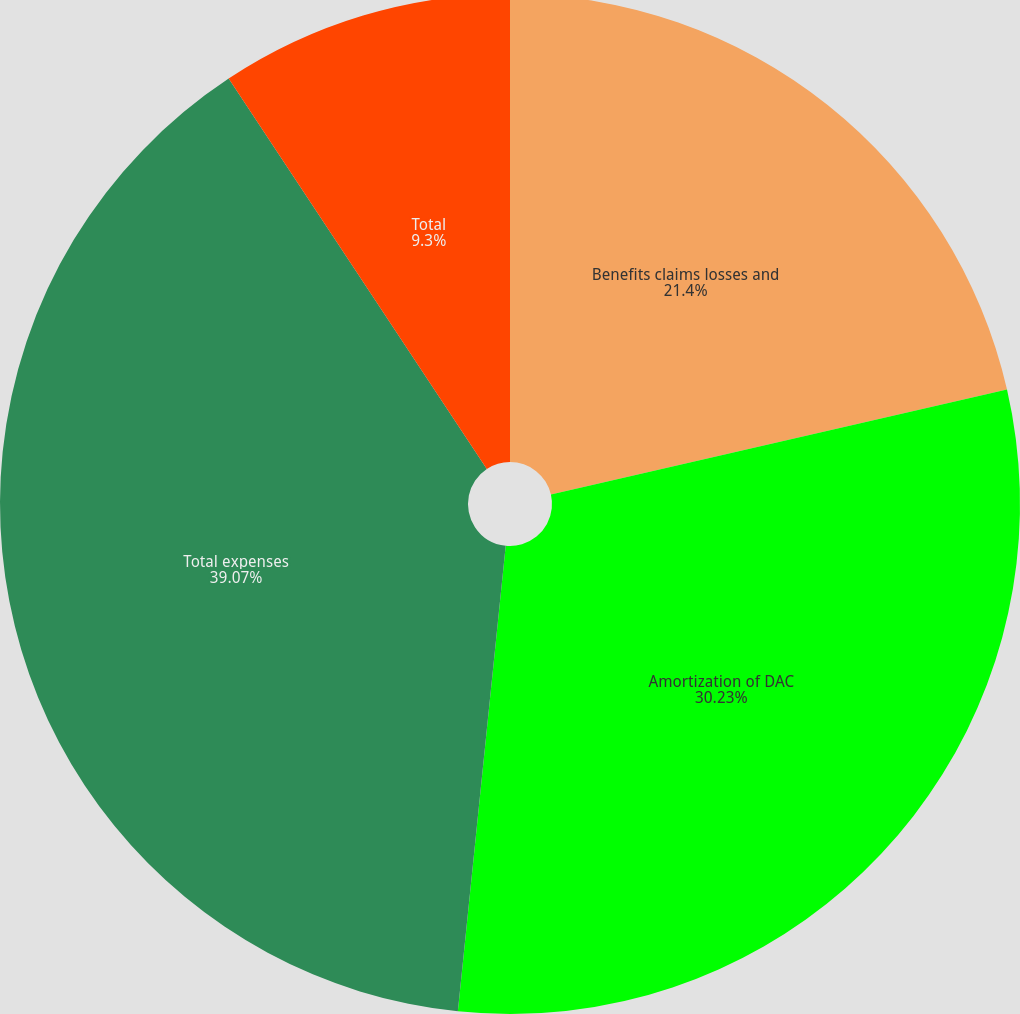Convert chart to OTSL. <chart><loc_0><loc_0><loc_500><loc_500><pie_chart><fcel>Benefits claims losses and<fcel>Amortization of DAC<fcel>Total expenses<fcel>Total<nl><fcel>21.4%<fcel>30.23%<fcel>39.07%<fcel>9.3%<nl></chart> 